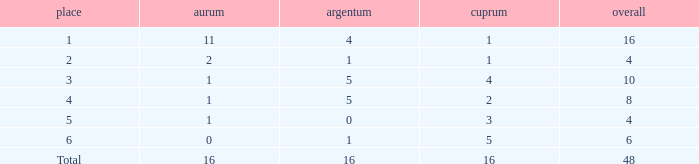What is the total gold that has bronze less than 2, a silver of 1 and total more than 4? None. 